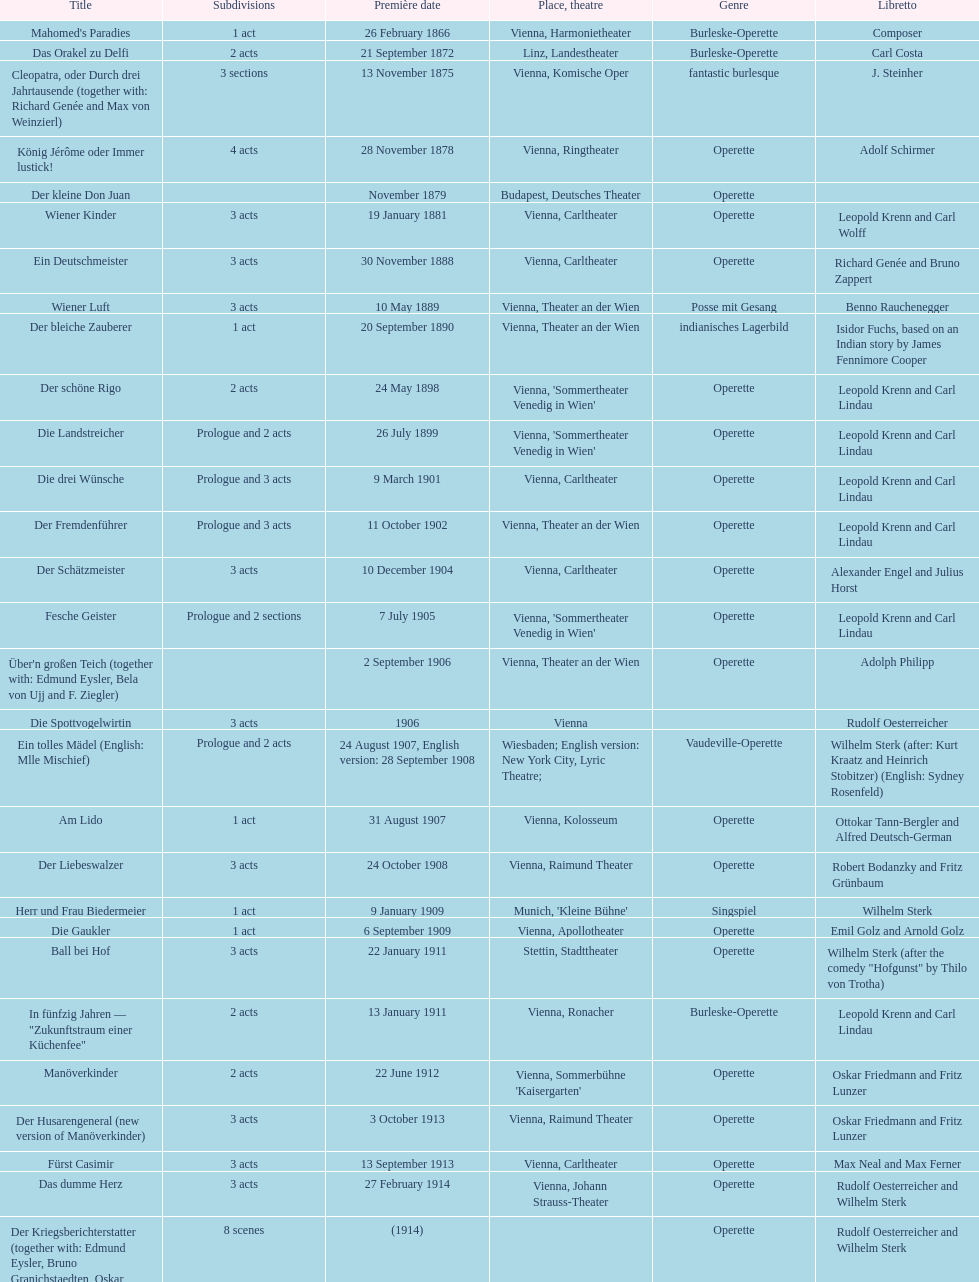What are the number of titles that premiered in the month of september? 4. Write the full table. {'header': ['Title', 'Sub\xaddivisions', 'Première date', 'Place, theatre', 'Genre', 'Libretto'], 'rows': [["Mahomed's Paradies", '1 act', '26 February 1866', 'Vienna, Harmonietheater', 'Burleske-Operette', 'Composer'], ['Das Orakel zu Delfi', '2 acts', '21 September 1872', 'Linz, Landestheater', 'Burleske-Operette', 'Carl Costa'], ['Cleopatra, oder Durch drei Jahrtausende (together with: Richard Genée and Max von Weinzierl)', '3 sections', '13 November 1875', 'Vienna, Komische Oper', 'fantastic burlesque', 'J. Steinher'], ['König Jérôme oder Immer lustick!', '4 acts', '28 November 1878', 'Vienna, Ringtheater', 'Operette', 'Adolf Schirmer'], ['Der kleine Don Juan', '', 'November 1879', 'Budapest, Deutsches Theater', 'Operette', ''], ['Wiener Kinder', '3 acts', '19 January 1881', 'Vienna, Carltheater', 'Operette', 'Leopold Krenn and Carl Wolff'], ['Ein Deutschmeister', '3 acts', '30 November 1888', 'Vienna, Carltheater', 'Operette', 'Richard Genée and Bruno Zappert'], ['Wiener Luft', '3 acts', '10 May 1889', 'Vienna, Theater an der Wien', 'Posse mit Gesang', 'Benno Rauchenegger'], ['Der bleiche Zauberer', '1 act', '20 September 1890', 'Vienna, Theater an der Wien', 'indianisches Lagerbild', 'Isidor Fuchs, based on an Indian story by James Fennimore Cooper'], ['Der schöne Rigo', '2 acts', '24 May 1898', "Vienna, 'Sommertheater Venedig in Wien'", 'Operette', 'Leopold Krenn and Carl Lindau'], ['Die Landstreicher', 'Prologue and 2 acts', '26 July 1899', "Vienna, 'Sommertheater Venedig in Wien'", 'Operette', 'Leopold Krenn and Carl Lindau'], ['Die drei Wünsche', 'Prologue and 3 acts', '9 March 1901', 'Vienna, Carltheater', 'Operette', 'Leopold Krenn and Carl Lindau'], ['Der Fremdenführer', 'Prologue and 3 acts', '11 October 1902', 'Vienna, Theater an der Wien', 'Operette', 'Leopold Krenn and Carl Lindau'], ['Der Schätzmeister', '3 acts', '10 December 1904', 'Vienna, Carltheater', 'Operette', 'Alexander Engel and Julius Horst'], ['Fesche Geister', 'Prologue and 2 sections', '7 July 1905', "Vienna, 'Sommertheater Venedig in Wien'", 'Operette', 'Leopold Krenn and Carl Lindau'], ["Über'n großen Teich (together with: Edmund Eysler, Bela von Ujj and F. Ziegler)", '', '2 September 1906', 'Vienna, Theater an der Wien', 'Operette', 'Adolph Philipp'], ['Die Spottvogelwirtin', '3 acts', '1906', 'Vienna', '', 'Rudolf Oesterreicher'], ['Ein tolles Mädel (English: Mlle Mischief)', 'Prologue and 2 acts', '24 August 1907, English version: 28 September 1908', 'Wiesbaden; English version: New York City, Lyric Theatre;', 'Vaudeville-Operette', 'Wilhelm Sterk (after: Kurt Kraatz and Heinrich Stobitzer) (English: Sydney Rosenfeld)'], ['Am Lido', '1 act', '31 August 1907', 'Vienna, Kolosseum', 'Operette', 'Ottokar Tann-Bergler and Alfred Deutsch-German'], ['Der Liebeswalzer', '3 acts', '24 October 1908', 'Vienna, Raimund Theater', 'Operette', 'Robert Bodanzky and Fritz Grünbaum'], ['Herr und Frau Biedermeier', '1 act', '9 January 1909', "Munich, 'Kleine Bühne'", 'Singspiel', 'Wilhelm Sterk'], ['Die Gaukler', '1 act', '6 September 1909', 'Vienna, Apollotheater', 'Operette', 'Emil Golz and Arnold Golz'], ['Ball bei Hof', '3 acts', '22 January 1911', 'Stettin, Stadttheater', 'Operette', 'Wilhelm Sterk (after the comedy "Hofgunst" by Thilo von Trotha)'], ['In fünfzig Jahren — "Zukunftstraum einer Küchenfee"', '2 acts', '13 January 1911', 'Vienna, Ronacher', 'Burleske-Operette', 'Leopold Krenn and Carl Lindau'], ['Manöverkinder', '2 acts', '22 June 1912', "Vienna, Sommerbühne 'Kaisergarten'", 'Operette', 'Oskar Friedmann and Fritz Lunzer'], ['Der Husarengeneral (new version of Manöverkinder)', '3 acts', '3 October 1913', 'Vienna, Raimund Theater', 'Operette', 'Oskar Friedmann and Fritz Lunzer'], ['Fürst Casimir', '3 acts', '13 September 1913', 'Vienna, Carltheater', 'Operette', 'Max Neal and Max Ferner'], ['Das dumme Herz', '3 acts', '27 February 1914', 'Vienna, Johann Strauss-Theater', 'Operette', 'Rudolf Oesterreicher and Wilhelm Sterk'], ['Der Kriegsberichterstatter (together with: Edmund Eysler, Bruno Granichstaedten, Oskar Nedbal, Charles Weinberger)', '8 scenes', '(1914)', '', 'Operette', 'Rudolf Oesterreicher and Wilhelm Sterk'], ['Im siebenten Himmel', '3 acts', '26 February 1916', 'Munich, Theater am Gärtnerplatz', 'Operette', 'Max Neal and Max Ferner'], ['Deutschmeisterkapelle', '', '30 May 1958', 'Vienna, Raimund Theater', 'Operette', 'Hubert Marischka and Rudolf Oesterreicher'], ['Die verliebte Eskadron', '3 acts', '11 July 1930', 'Vienna, Johann-Strauß-Theater', 'Operette', 'Wilhelm Sterk (after B. Buchbinder)']]} 